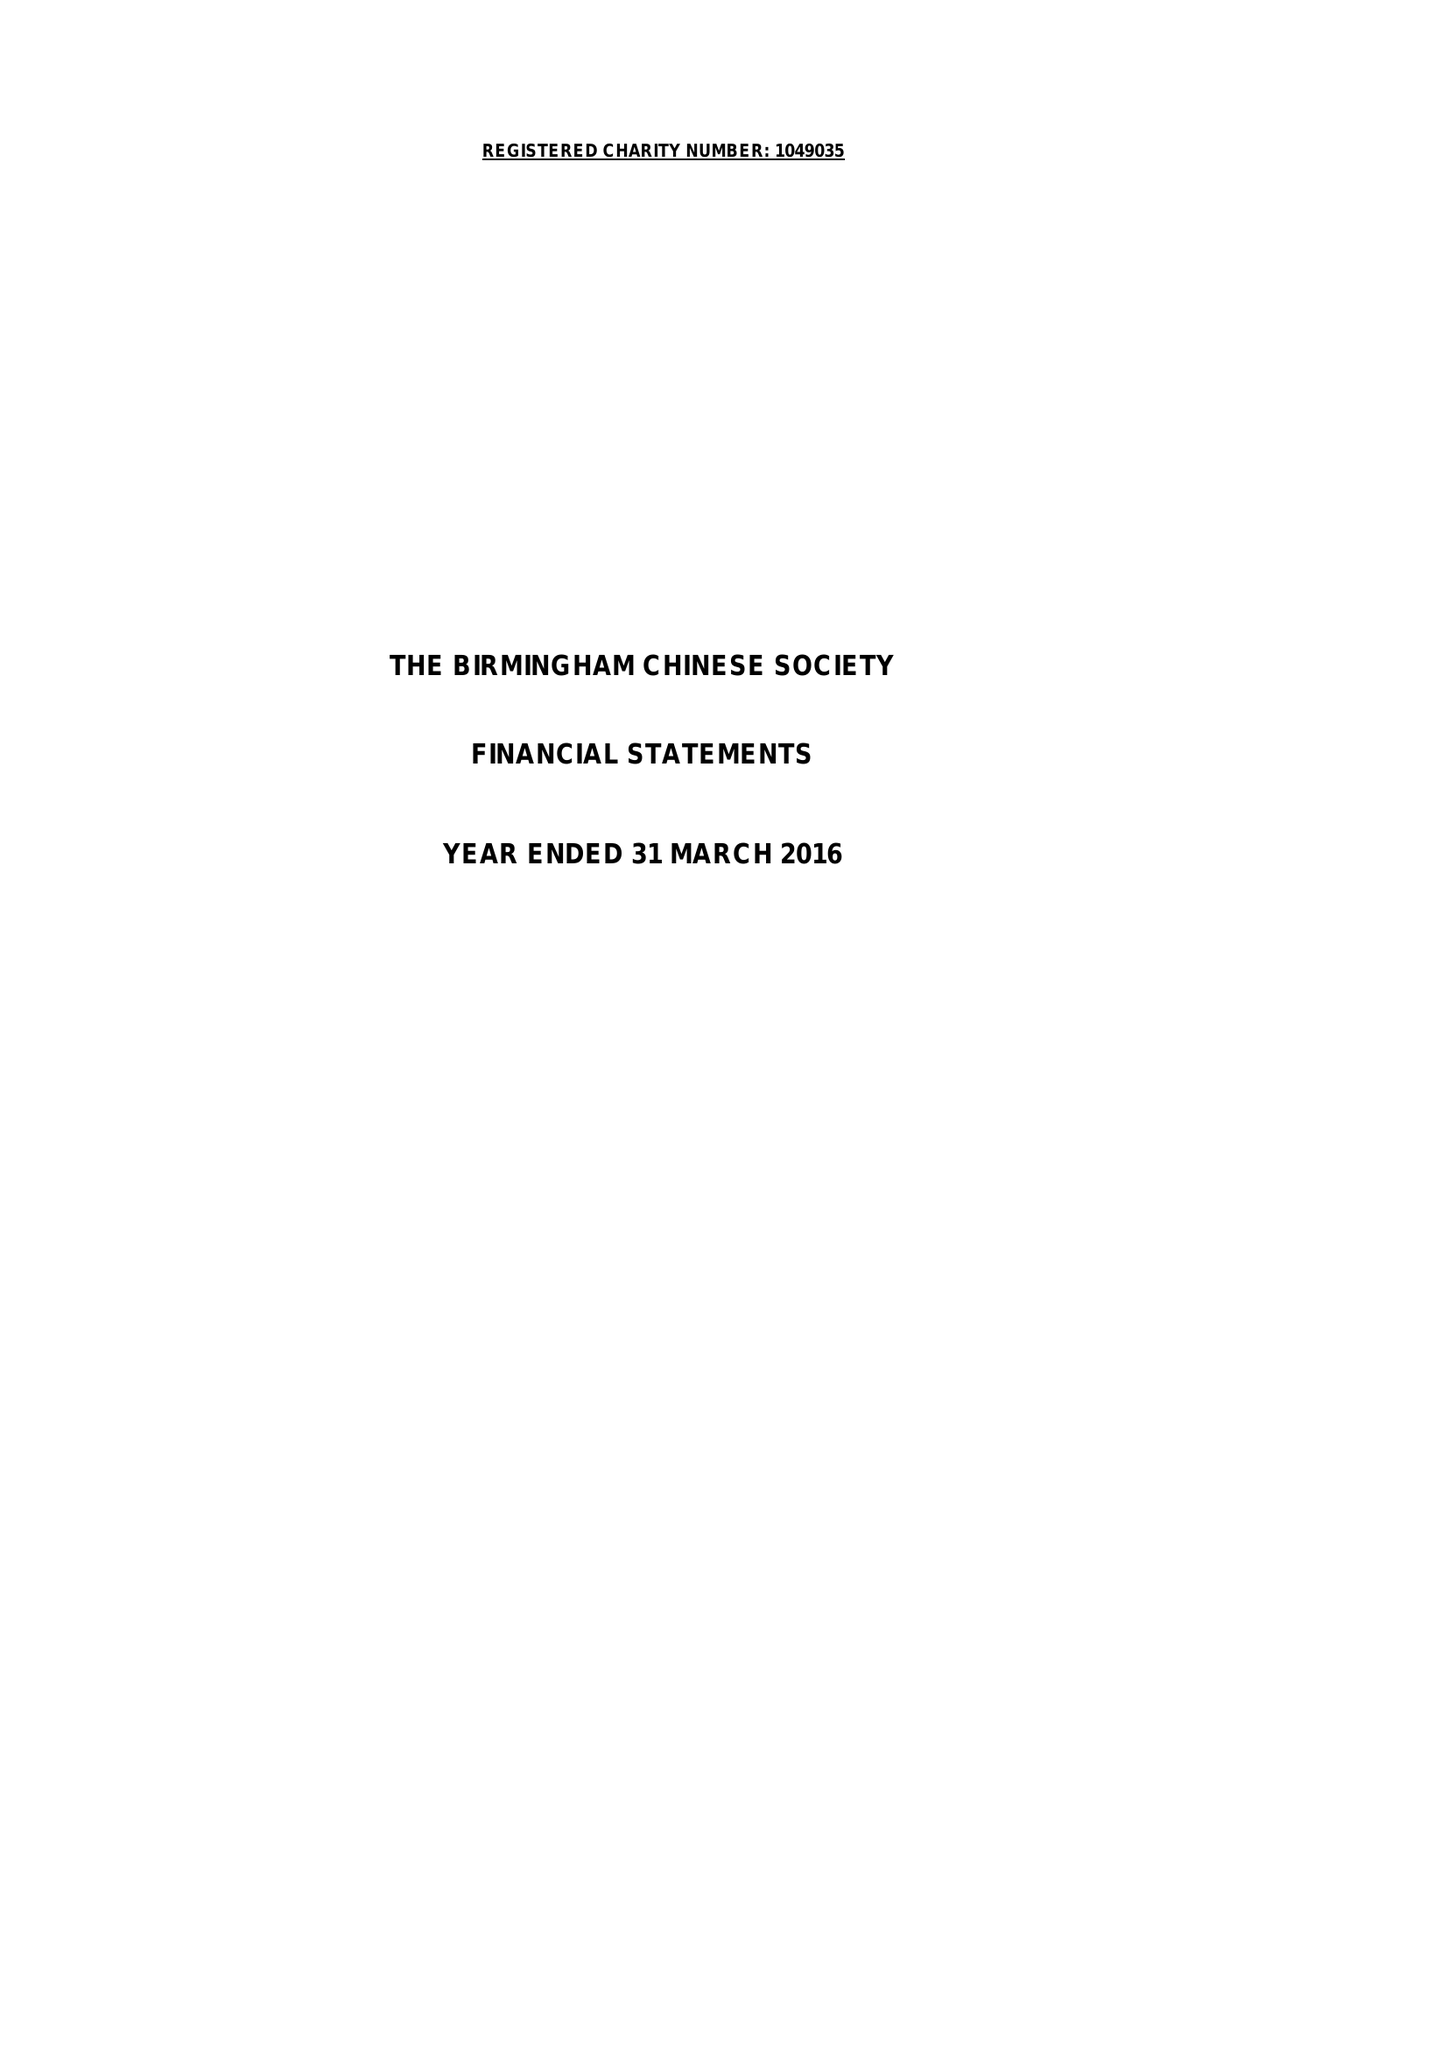What is the value for the charity_name?
Answer the question using a single word or phrase. The Birmingham Chinese Society 